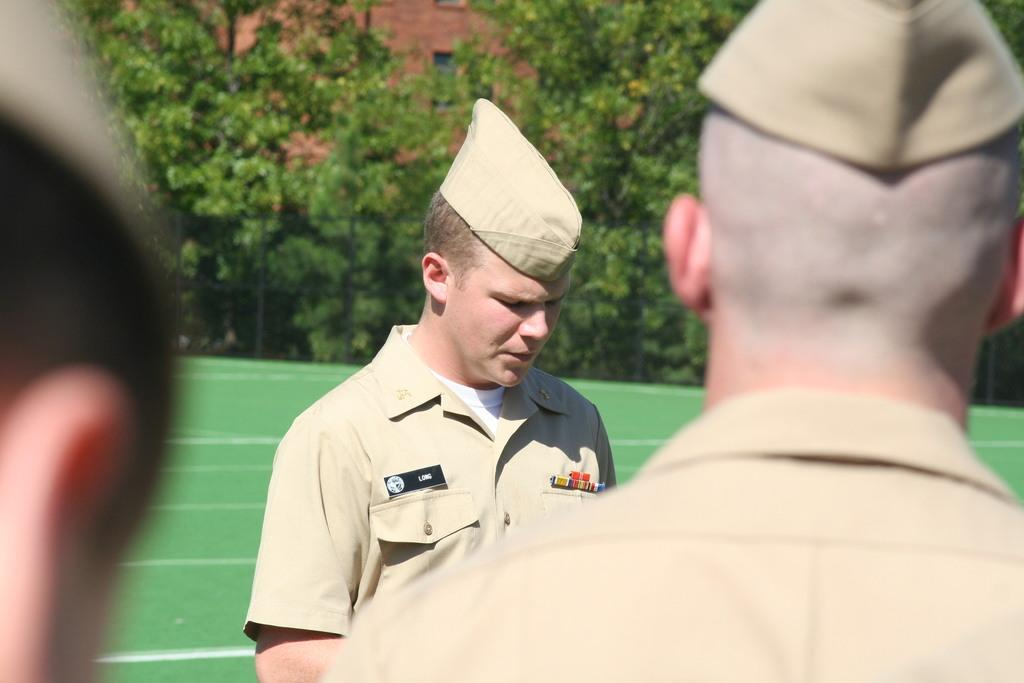How many people are in the image? There are three people in the image. What is the position of the people in the image? The people are on the ground. What can be seen in the image besides the people? There is a fence, trees, and a building in the background of the image. Can you describe the building in the background? The building has a window. What type of bun is being used to cover the wound on the person's head in the image? There is no bun or wound present in the image; the people are simply on the ground. 